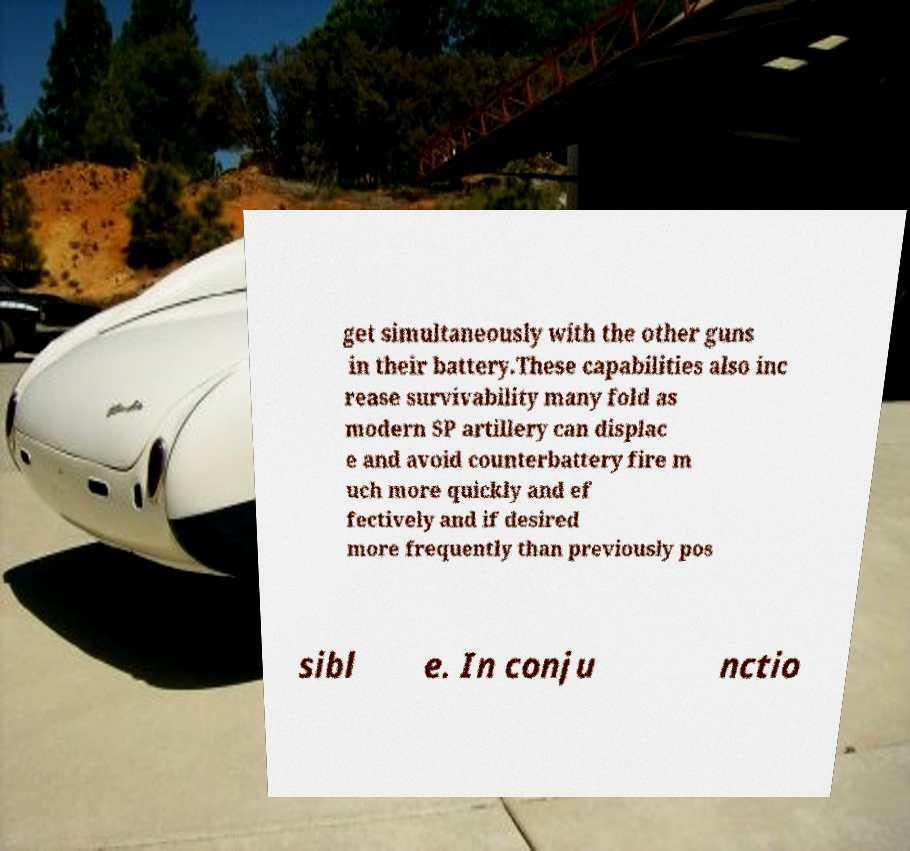For documentation purposes, I need the text within this image transcribed. Could you provide that? get simultaneously with the other guns in their battery.These capabilities also inc rease survivability many fold as modern SP artillery can displac e and avoid counterbattery fire m uch more quickly and ef fectively and if desired more frequently than previously pos sibl e. In conju nctio 